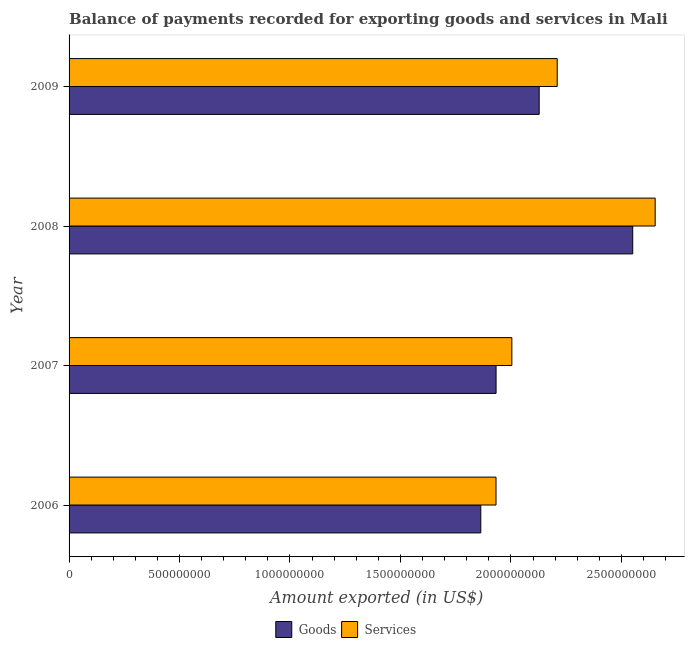How many different coloured bars are there?
Keep it short and to the point. 2. Are the number of bars per tick equal to the number of legend labels?
Offer a terse response. Yes. How many bars are there on the 1st tick from the top?
Offer a terse response. 2. What is the amount of services exported in 2006?
Give a very brief answer. 1.93e+09. Across all years, what is the maximum amount of services exported?
Ensure brevity in your answer.  2.65e+09. Across all years, what is the minimum amount of services exported?
Ensure brevity in your answer.  1.93e+09. In which year was the amount of goods exported minimum?
Your answer should be compact. 2006. What is the total amount of services exported in the graph?
Keep it short and to the point. 8.80e+09. What is the difference between the amount of services exported in 2008 and that in 2009?
Offer a terse response. 4.43e+08. What is the difference between the amount of services exported in 2006 and the amount of goods exported in 2009?
Make the answer very short. -1.95e+08. What is the average amount of goods exported per year?
Offer a very short reply. 2.12e+09. In the year 2006, what is the difference between the amount of goods exported and amount of services exported?
Offer a terse response. -6.90e+07. What is the ratio of the amount of goods exported in 2007 to that in 2008?
Keep it short and to the point. 0.76. Is the amount of goods exported in 2006 less than that in 2009?
Your response must be concise. Yes. What is the difference between the highest and the second highest amount of services exported?
Keep it short and to the point. 4.43e+08. What is the difference between the highest and the lowest amount of services exported?
Your response must be concise. 7.21e+08. Is the sum of the amount of goods exported in 2006 and 2007 greater than the maximum amount of services exported across all years?
Make the answer very short. Yes. What does the 2nd bar from the top in 2008 represents?
Offer a very short reply. Goods. What does the 2nd bar from the bottom in 2006 represents?
Offer a very short reply. Services. How many years are there in the graph?
Your answer should be very brief. 4. What is the difference between two consecutive major ticks on the X-axis?
Give a very brief answer. 5.00e+08. Are the values on the major ticks of X-axis written in scientific E-notation?
Provide a succinct answer. No. Does the graph contain any zero values?
Your answer should be compact. No. How many legend labels are there?
Your response must be concise. 2. How are the legend labels stacked?
Offer a very short reply. Horizontal. What is the title of the graph?
Provide a succinct answer. Balance of payments recorded for exporting goods and services in Mali. Does "Male population" appear as one of the legend labels in the graph?
Provide a short and direct response. No. What is the label or title of the X-axis?
Provide a short and direct response. Amount exported (in US$). What is the Amount exported (in US$) in Goods in 2006?
Make the answer very short. 1.86e+09. What is the Amount exported (in US$) of Services in 2006?
Your answer should be compact. 1.93e+09. What is the Amount exported (in US$) of Goods in 2007?
Offer a very short reply. 1.93e+09. What is the Amount exported (in US$) of Services in 2007?
Provide a short and direct response. 2.00e+09. What is the Amount exported (in US$) of Goods in 2008?
Keep it short and to the point. 2.55e+09. What is the Amount exported (in US$) of Services in 2008?
Give a very brief answer. 2.65e+09. What is the Amount exported (in US$) in Goods in 2009?
Provide a short and direct response. 2.13e+09. What is the Amount exported (in US$) in Services in 2009?
Ensure brevity in your answer.  2.21e+09. Across all years, what is the maximum Amount exported (in US$) of Goods?
Provide a succinct answer. 2.55e+09. Across all years, what is the maximum Amount exported (in US$) in Services?
Keep it short and to the point. 2.65e+09. Across all years, what is the minimum Amount exported (in US$) in Goods?
Provide a succinct answer. 1.86e+09. Across all years, what is the minimum Amount exported (in US$) of Services?
Give a very brief answer. 1.93e+09. What is the total Amount exported (in US$) of Goods in the graph?
Give a very brief answer. 8.48e+09. What is the total Amount exported (in US$) in Services in the graph?
Your answer should be very brief. 8.80e+09. What is the difference between the Amount exported (in US$) in Goods in 2006 and that in 2007?
Offer a very short reply. -6.93e+07. What is the difference between the Amount exported (in US$) in Services in 2006 and that in 2007?
Give a very brief answer. -7.17e+07. What is the difference between the Amount exported (in US$) of Goods in 2006 and that in 2008?
Give a very brief answer. -6.88e+08. What is the difference between the Amount exported (in US$) in Services in 2006 and that in 2008?
Make the answer very short. -7.21e+08. What is the difference between the Amount exported (in US$) in Goods in 2006 and that in 2009?
Keep it short and to the point. -2.64e+08. What is the difference between the Amount exported (in US$) in Services in 2006 and that in 2009?
Offer a very short reply. -2.77e+08. What is the difference between the Amount exported (in US$) of Goods in 2007 and that in 2008?
Provide a succinct answer. -6.19e+08. What is the difference between the Amount exported (in US$) of Services in 2007 and that in 2008?
Keep it short and to the point. -6.49e+08. What is the difference between the Amount exported (in US$) of Goods in 2007 and that in 2009?
Give a very brief answer. -1.95e+08. What is the difference between the Amount exported (in US$) in Services in 2007 and that in 2009?
Keep it short and to the point. -2.05e+08. What is the difference between the Amount exported (in US$) of Goods in 2008 and that in 2009?
Give a very brief answer. 4.23e+08. What is the difference between the Amount exported (in US$) of Services in 2008 and that in 2009?
Ensure brevity in your answer.  4.43e+08. What is the difference between the Amount exported (in US$) of Goods in 2006 and the Amount exported (in US$) of Services in 2007?
Ensure brevity in your answer.  -1.41e+08. What is the difference between the Amount exported (in US$) in Goods in 2006 and the Amount exported (in US$) in Services in 2008?
Ensure brevity in your answer.  -7.89e+08. What is the difference between the Amount exported (in US$) of Goods in 2006 and the Amount exported (in US$) of Services in 2009?
Your answer should be very brief. -3.46e+08. What is the difference between the Amount exported (in US$) in Goods in 2007 and the Amount exported (in US$) in Services in 2008?
Ensure brevity in your answer.  -7.20e+08. What is the difference between the Amount exported (in US$) in Goods in 2007 and the Amount exported (in US$) in Services in 2009?
Provide a succinct answer. -2.77e+08. What is the difference between the Amount exported (in US$) in Goods in 2008 and the Amount exported (in US$) in Services in 2009?
Your answer should be compact. 3.42e+08. What is the average Amount exported (in US$) in Goods per year?
Your response must be concise. 2.12e+09. What is the average Amount exported (in US$) of Services per year?
Your answer should be very brief. 2.20e+09. In the year 2006, what is the difference between the Amount exported (in US$) in Goods and Amount exported (in US$) in Services?
Your response must be concise. -6.90e+07. In the year 2007, what is the difference between the Amount exported (in US$) of Goods and Amount exported (in US$) of Services?
Ensure brevity in your answer.  -7.14e+07. In the year 2008, what is the difference between the Amount exported (in US$) in Goods and Amount exported (in US$) in Services?
Provide a succinct answer. -1.02e+08. In the year 2009, what is the difference between the Amount exported (in US$) of Goods and Amount exported (in US$) of Services?
Offer a very short reply. -8.16e+07. What is the ratio of the Amount exported (in US$) in Goods in 2006 to that in 2007?
Ensure brevity in your answer.  0.96. What is the ratio of the Amount exported (in US$) of Services in 2006 to that in 2007?
Ensure brevity in your answer.  0.96. What is the ratio of the Amount exported (in US$) in Goods in 2006 to that in 2008?
Provide a short and direct response. 0.73. What is the ratio of the Amount exported (in US$) in Services in 2006 to that in 2008?
Your response must be concise. 0.73. What is the ratio of the Amount exported (in US$) of Goods in 2006 to that in 2009?
Ensure brevity in your answer.  0.88. What is the ratio of the Amount exported (in US$) of Services in 2006 to that in 2009?
Provide a short and direct response. 0.87. What is the ratio of the Amount exported (in US$) in Goods in 2007 to that in 2008?
Give a very brief answer. 0.76. What is the ratio of the Amount exported (in US$) in Services in 2007 to that in 2008?
Your answer should be compact. 0.76. What is the ratio of the Amount exported (in US$) of Goods in 2007 to that in 2009?
Provide a succinct answer. 0.91. What is the ratio of the Amount exported (in US$) of Services in 2007 to that in 2009?
Make the answer very short. 0.91. What is the ratio of the Amount exported (in US$) of Goods in 2008 to that in 2009?
Your answer should be very brief. 1.2. What is the ratio of the Amount exported (in US$) in Services in 2008 to that in 2009?
Provide a short and direct response. 1.2. What is the difference between the highest and the second highest Amount exported (in US$) of Goods?
Provide a succinct answer. 4.23e+08. What is the difference between the highest and the second highest Amount exported (in US$) of Services?
Give a very brief answer. 4.43e+08. What is the difference between the highest and the lowest Amount exported (in US$) of Goods?
Provide a short and direct response. 6.88e+08. What is the difference between the highest and the lowest Amount exported (in US$) of Services?
Provide a succinct answer. 7.21e+08. 